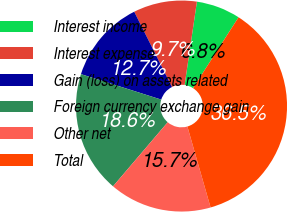Convert chart to OTSL. <chart><loc_0><loc_0><loc_500><loc_500><pie_chart><fcel>Interest income<fcel>Interest expense<fcel>Gain (loss) on assets related<fcel>Foreign currency exchange gain<fcel>Other net<fcel>Total<nl><fcel>6.76%<fcel>9.73%<fcel>12.71%<fcel>18.65%<fcel>15.68%<fcel>36.47%<nl></chart> 